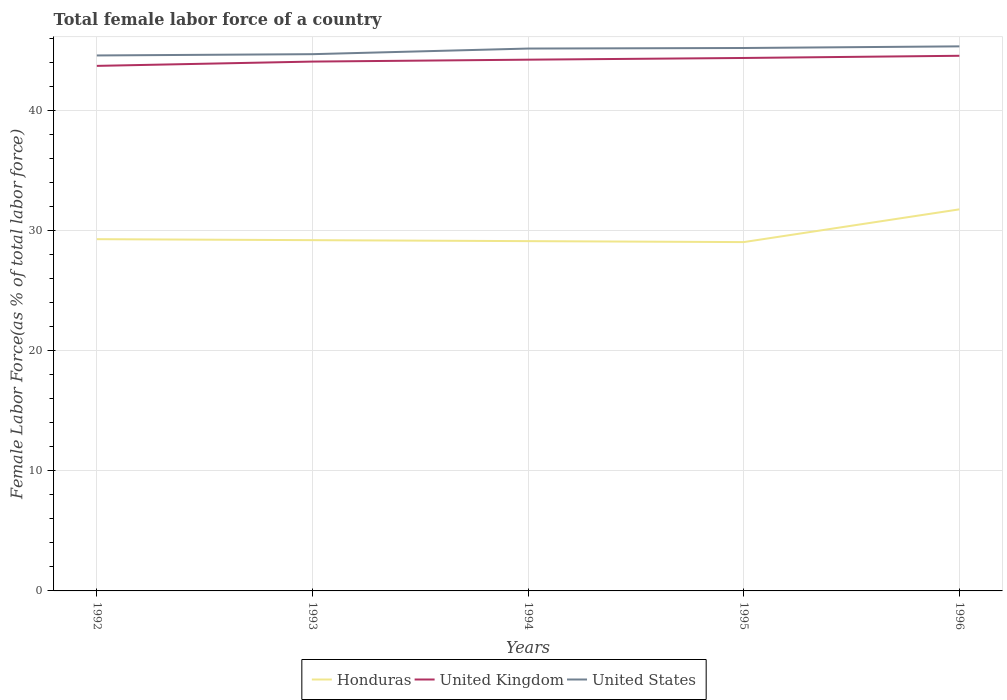Does the line corresponding to United States intersect with the line corresponding to United Kingdom?
Ensure brevity in your answer.  No. Across all years, what is the maximum percentage of female labor force in Honduras?
Provide a succinct answer. 29.04. What is the total percentage of female labor force in United States in the graph?
Your answer should be compact. -0.51. What is the difference between the highest and the second highest percentage of female labor force in United States?
Offer a terse response. 0.76. What is the difference between the highest and the lowest percentage of female labor force in Honduras?
Give a very brief answer. 1. Is the percentage of female labor force in United States strictly greater than the percentage of female labor force in United Kingdom over the years?
Make the answer very short. No. How many years are there in the graph?
Provide a succinct answer. 5. What is the difference between two consecutive major ticks on the Y-axis?
Offer a very short reply. 10. Are the values on the major ticks of Y-axis written in scientific E-notation?
Provide a succinct answer. No. Does the graph contain grids?
Your response must be concise. Yes. Where does the legend appear in the graph?
Offer a very short reply. Bottom center. What is the title of the graph?
Your answer should be very brief. Total female labor force of a country. Does "Burundi" appear as one of the legend labels in the graph?
Ensure brevity in your answer.  No. What is the label or title of the X-axis?
Make the answer very short. Years. What is the label or title of the Y-axis?
Provide a succinct answer. Female Labor Force(as % of total labor force). What is the Female Labor Force(as % of total labor force) in Honduras in 1992?
Your answer should be compact. 29.29. What is the Female Labor Force(as % of total labor force) of United Kingdom in 1992?
Your answer should be very brief. 43.72. What is the Female Labor Force(as % of total labor force) of United States in 1992?
Keep it short and to the point. 44.58. What is the Female Labor Force(as % of total labor force) of Honduras in 1993?
Your response must be concise. 29.2. What is the Female Labor Force(as % of total labor force) in United Kingdom in 1993?
Ensure brevity in your answer.  44.07. What is the Female Labor Force(as % of total labor force) in United States in 1993?
Give a very brief answer. 44.69. What is the Female Labor Force(as % of total labor force) of Honduras in 1994?
Ensure brevity in your answer.  29.12. What is the Female Labor Force(as % of total labor force) in United Kingdom in 1994?
Offer a very short reply. 44.23. What is the Female Labor Force(as % of total labor force) in United States in 1994?
Provide a succinct answer. 45.16. What is the Female Labor Force(as % of total labor force) in Honduras in 1995?
Your answer should be very brief. 29.04. What is the Female Labor Force(as % of total labor force) in United Kingdom in 1995?
Offer a terse response. 44.37. What is the Female Labor Force(as % of total labor force) in United States in 1995?
Give a very brief answer. 45.2. What is the Female Labor Force(as % of total labor force) of Honduras in 1996?
Offer a very short reply. 31.77. What is the Female Labor Force(as % of total labor force) in United Kingdom in 1996?
Keep it short and to the point. 44.56. What is the Female Labor Force(as % of total labor force) in United States in 1996?
Ensure brevity in your answer.  45.34. Across all years, what is the maximum Female Labor Force(as % of total labor force) of Honduras?
Provide a succinct answer. 31.77. Across all years, what is the maximum Female Labor Force(as % of total labor force) in United Kingdom?
Ensure brevity in your answer.  44.56. Across all years, what is the maximum Female Labor Force(as % of total labor force) of United States?
Your response must be concise. 45.34. Across all years, what is the minimum Female Labor Force(as % of total labor force) of Honduras?
Your answer should be very brief. 29.04. Across all years, what is the minimum Female Labor Force(as % of total labor force) in United Kingdom?
Your answer should be very brief. 43.72. Across all years, what is the minimum Female Labor Force(as % of total labor force) of United States?
Make the answer very short. 44.58. What is the total Female Labor Force(as % of total labor force) of Honduras in the graph?
Ensure brevity in your answer.  148.43. What is the total Female Labor Force(as % of total labor force) of United Kingdom in the graph?
Make the answer very short. 220.95. What is the total Female Labor Force(as % of total labor force) of United States in the graph?
Offer a terse response. 224.97. What is the difference between the Female Labor Force(as % of total labor force) in Honduras in 1992 and that in 1993?
Offer a terse response. 0.08. What is the difference between the Female Labor Force(as % of total labor force) of United Kingdom in 1992 and that in 1993?
Provide a short and direct response. -0.36. What is the difference between the Female Labor Force(as % of total labor force) of United States in 1992 and that in 1993?
Provide a short and direct response. -0.11. What is the difference between the Female Labor Force(as % of total labor force) of Honduras in 1992 and that in 1994?
Ensure brevity in your answer.  0.16. What is the difference between the Female Labor Force(as % of total labor force) in United Kingdom in 1992 and that in 1994?
Your answer should be compact. -0.52. What is the difference between the Female Labor Force(as % of total labor force) in United States in 1992 and that in 1994?
Ensure brevity in your answer.  -0.58. What is the difference between the Female Labor Force(as % of total labor force) of Honduras in 1992 and that in 1995?
Provide a succinct answer. 0.24. What is the difference between the Female Labor Force(as % of total labor force) in United Kingdom in 1992 and that in 1995?
Keep it short and to the point. -0.66. What is the difference between the Female Labor Force(as % of total labor force) of United States in 1992 and that in 1995?
Offer a terse response. -0.62. What is the difference between the Female Labor Force(as % of total labor force) of Honduras in 1992 and that in 1996?
Offer a terse response. -2.48. What is the difference between the Female Labor Force(as % of total labor force) in United Kingdom in 1992 and that in 1996?
Offer a terse response. -0.84. What is the difference between the Female Labor Force(as % of total labor force) of United States in 1992 and that in 1996?
Give a very brief answer. -0.76. What is the difference between the Female Labor Force(as % of total labor force) of Honduras in 1993 and that in 1994?
Offer a terse response. 0.08. What is the difference between the Female Labor Force(as % of total labor force) of United Kingdom in 1993 and that in 1994?
Keep it short and to the point. -0.16. What is the difference between the Female Labor Force(as % of total labor force) in United States in 1993 and that in 1994?
Offer a very short reply. -0.47. What is the difference between the Female Labor Force(as % of total labor force) of Honduras in 1993 and that in 1995?
Provide a short and direct response. 0.16. What is the difference between the Female Labor Force(as % of total labor force) of United Kingdom in 1993 and that in 1995?
Offer a terse response. -0.3. What is the difference between the Female Labor Force(as % of total labor force) in United States in 1993 and that in 1995?
Your answer should be very brief. -0.51. What is the difference between the Female Labor Force(as % of total labor force) of Honduras in 1993 and that in 1996?
Your answer should be compact. -2.57. What is the difference between the Female Labor Force(as % of total labor force) in United Kingdom in 1993 and that in 1996?
Offer a terse response. -0.48. What is the difference between the Female Labor Force(as % of total labor force) in United States in 1993 and that in 1996?
Give a very brief answer. -0.65. What is the difference between the Female Labor Force(as % of total labor force) in Honduras in 1994 and that in 1995?
Your answer should be very brief. 0.08. What is the difference between the Female Labor Force(as % of total labor force) in United Kingdom in 1994 and that in 1995?
Offer a very short reply. -0.14. What is the difference between the Female Labor Force(as % of total labor force) in United States in 1994 and that in 1995?
Your answer should be compact. -0.05. What is the difference between the Female Labor Force(as % of total labor force) in Honduras in 1994 and that in 1996?
Keep it short and to the point. -2.65. What is the difference between the Female Labor Force(as % of total labor force) in United Kingdom in 1994 and that in 1996?
Ensure brevity in your answer.  -0.32. What is the difference between the Female Labor Force(as % of total labor force) of United States in 1994 and that in 1996?
Give a very brief answer. -0.18. What is the difference between the Female Labor Force(as % of total labor force) in Honduras in 1995 and that in 1996?
Your response must be concise. -2.73. What is the difference between the Female Labor Force(as % of total labor force) in United Kingdom in 1995 and that in 1996?
Ensure brevity in your answer.  -0.18. What is the difference between the Female Labor Force(as % of total labor force) in United States in 1995 and that in 1996?
Offer a terse response. -0.14. What is the difference between the Female Labor Force(as % of total labor force) in Honduras in 1992 and the Female Labor Force(as % of total labor force) in United Kingdom in 1993?
Give a very brief answer. -14.79. What is the difference between the Female Labor Force(as % of total labor force) of Honduras in 1992 and the Female Labor Force(as % of total labor force) of United States in 1993?
Your answer should be very brief. -15.4. What is the difference between the Female Labor Force(as % of total labor force) of United Kingdom in 1992 and the Female Labor Force(as % of total labor force) of United States in 1993?
Keep it short and to the point. -0.97. What is the difference between the Female Labor Force(as % of total labor force) of Honduras in 1992 and the Female Labor Force(as % of total labor force) of United Kingdom in 1994?
Ensure brevity in your answer.  -14.94. What is the difference between the Female Labor Force(as % of total labor force) in Honduras in 1992 and the Female Labor Force(as % of total labor force) in United States in 1994?
Provide a short and direct response. -15.87. What is the difference between the Female Labor Force(as % of total labor force) of United Kingdom in 1992 and the Female Labor Force(as % of total labor force) of United States in 1994?
Your answer should be very brief. -1.44. What is the difference between the Female Labor Force(as % of total labor force) in Honduras in 1992 and the Female Labor Force(as % of total labor force) in United Kingdom in 1995?
Make the answer very short. -15.09. What is the difference between the Female Labor Force(as % of total labor force) in Honduras in 1992 and the Female Labor Force(as % of total labor force) in United States in 1995?
Offer a terse response. -15.92. What is the difference between the Female Labor Force(as % of total labor force) of United Kingdom in 1992 and the Female Labor Force(as % of total labor force) of United States in 1995?
Your response must be concise. -1.49. What is the difference between the Female Labor Force(as % of total labor force) of Honduras in 1992 and the Female Labor Force(as % of total labor force) of United Kingdom in 1996?
Provide a succinct answer. -15.27. What is the difference between the Female Labor Force(as % of total labor force) in Honduras in 1992 and the Female Labor Force(as % of total labor force) in United States in 1996?
Keep it short and to the point. -16.05. What is the difference between the Female Labor Force(as % of total labor force) in United Kingdom in 1992 and the Female Labor Force(as % of total labor force) in United States in 1996?
Your answer should be very brief. -1.62. What is the difference between the Female Labor Force(as % of total labor force) in Honduras in 1993 and the Female Labor Force(as % of total labor force) in United Kingdom in 1994?
Your answer should be very brief. -15.03. What is the difference between the Female Labor Force(as % of total labor force) of Honduras in 1993 and the Female Labor Force(as % of total labor force) of United States in 1994?
Provide a succinct answer. -15.95. What is the difference between the Female Labor Force(as % of total labor force) in United Kingdom in 1993 and the Female Labor Force(as % of total labor force) in United States in 1994?
Your response must be concise. -1.08. What is the difference between the Female Labor Force(as % of total labor force) of Honduras in 1993 and the Female Labor Force(as % of total labor force) of United Kingdom in 1995?
Your answer should be compact. -15.17. What is the difference between the Female Labor Force(as % of total labor force) in Honduras in 1993 and the Female Labor Force(as % of total labor force) in United States in 1995?
Your answer should be compact. -16. What is the difference between the Female Labor Force(as % of total labor force) of United Kingdom in 1993 and the Female Labor Force(as % of total labor force) of United States in 1995?
Provide a succinct answer. -1.13. What is the difference between the Female Labor Force(as % of total labor force) in Honduras in 1993 and the Female Labor Force(as % of total labor force) in United Kingdom in 1996?
Make the answer very short. -15.35. What is the difference between the Female Labor Force(as % of total labor force) of Honduras in 1993 and the Female Labor Force(as % of total labor force) of United States in 1996?
Provide a short and direct response. -16.14. What is the difference between the Female Labor Force(as % of total labor force) of United Kingdom in 1993 and the Female Labor Force(as % of total labor force) of United States in 1996?
Your response must be concise. -1.27. What is the difference between the Female Labor Force(as % of total labor force) in Honduras in 1994 and the Female Labor Force(as % of total labor force) in United Kingdom in 1995?
Give a very brief answer. -15.25. What is the difference between the Female Labor Force(as % of total labor force) of Honduras in 1994 and the Female Labor Force(as % of total labor force) of United States in 1995?
Your response must be concise. -16.08. What is the difference between the Female Labor Force(as % of total labor force) in United Kingdom in 1994 and the Female Labor Force(as % of total labor force) in United States in 1995?
Your response must be concise. -0.97. What is the difference between the Female Labor Force(as % of total labor force) of Honduras in 1994 and the Female Labor Force(as % of total labor force) of United Kingdom in 1996?
Give a very brief answer. -15.43. What is the difference between the Female Labor Force(as % of total labor force) of Honduras in 1994 and the Female Labor Force(as % of total labor force) of United States in 1996?
Your answer should be compact. -16.22. What is the difference between the Female Labor Force(as % of total labor force) of United Kingdom in 1994 and the Female Labor Force(as % of total labor force) of United States in 1996?
Make the answer very short. -1.11. What is the difference between the Female Labor Force(as % of total labor force) of Honduras in 1995 and the Female Labor Force(as % of total labor force) of United Kingdom in 1996?
Provide a short and direct response. -15.51. What is the difference between the Female Labor Force(as % of total labor force) in Honduras in 1995 and the Female Labor Force(as % of total labor force) in United States in 1996?
Keep it short and to the point. -16.3. What is the difference between the Female Labor Force(as % of total labor force) of United Kingdom in 1995 and the Female Labor Force(as % of total labor force) of United States in 1996?
Offer a very short reply. -0.97. What is the average Female Labor Force(as % of total labor force) of Honduras per year?
Your response must be concise. 29.69. What is the average Female Labor Force(as % of total labor force) of United Kingdom per year?
Offer a very short reply. 44.19. What is the average Female Labor Force(as % of total labor force) of United States per year?
Ensure brevity in your answer.  44.99. In the year 1992, what is the difference between the Female Labor Force(as % of total labor force) of Honduras and Female Labor Force(as % of total labor force) of United Kingdom?
Offer a terse response. -14.43. In the year 1992, what is the difference between the Female Labor Force(as % of total labor force) in Honduras and Female Labor Force(as % of total labor force) in United States?
Provide a succinct answer. -15.3. In the year 1992, what is the difference between the Female Labor Force(as % of total labor force) in United Kingdom and Female Labor Force(as % of total labor force) in United States?
Ensure brevity in your answer.  -0.87. In the year 1993, what is the difference between the Female Labor Force(as % of total labor force) of Honduras and Female Labor Force(as % of total labor force) of United Kingdom?
Ensure brevity in your answer.  -14.87. In the year 1993, what is the difference between the Female Labor Force(as % of total labor force) of Honduras and Female Labor Force(as % of total labor force) of United States?
Offer a terse response. -15.49. In the year 1993, what is the difference between the Female Labor Force(as % of total labor force) in United Kingdom and Female Labor Force(as % of total labor force) in United States?
Offer a very short reply. -0.62. In the year 1994, what is the difference between the Female Labor Force(as % of total labor force) of Honduras and Female Labor Force(as % of total labor force) of United Kingdom?
Offer a very short reply. -15.11. In the year 1994, what is the difference between the Female Labor Force(as % of total labor force) in Honduras and Female Labor Force(as % of total labor force) in United States?
Keep it short and to the point. -16.03. In the year 1994, what is the difference between the Female Labor Force(as % of total labor force) in United Kingdom and Female Labor Force(as % of total labor force) in United States?
Make the answer very short. -0.93. In the year 1995, what is the difference between the Female Labor Force(as % of total labor force) of Honduras and Female Labor Force(as % of total labor force) of United Kingdom?
Your answer should be compact. -15.33. In the year 1995, what is the difference between the Female Labor Force(as % of total labor force) in Honduras and Female Labor Force(as % of total labor force) in United States?
Offer a terse response. -16.16. In the year 1995, what is the difference between the Female Labor Force(as % of total labor force) of United Kingdom and Female Labor Force(as % of total labor force) of United States?
Offer a terse response. -0.83. In the year 1996, what is the difference between the Female Labor Force(as % of total labor force) in Honduras and Female Labor Force(as % of total labor force) in United Kingdom?
Make the answer very short. -12.79. In the year 1996, what is the difference between the Female Labor Force(as % of total labor force) in Honduras and Female Labor Force(as % of total labor force) in United States?
Ensure brevity in your answer.  -13.57. In the year 1996, what is the difference between the Female Labor Force(as % of total labor force) of United Kingdom and Female Labor Force(as % of total labor force) of United States?
Offer a very short reply. -0.78. What is the ratio of the Female Labor Force(as % of total labor force) of United Kingdom in 1992 to that in 1993?
Your answer should be compact. 0.99. What is the ratio of the Female Labor Force(as % of total labor force) of Honduras in 1992 to that in 1994?
Offer a very short reply. 1.01. What is the ratio of the Female Labor Force(as % of total labor force) in United Kingdom in 1992 to that in 1994?
Give a very brief answer. 0.99. What is the ratio of the Female Labor Force(as % of total labor force) in United States in 1992 to that in 1994?
Provide a succinct answer. 0.99. What is the ratio of the Female Labor Force(as % of total labor force) in Honduras in 1992 to that in 1995?
Ensure brevity in your answer.  1.01. What is the ratio of the Female Labor Force(as % of total labor force) in United Kingdom in 1992 to that in 1995?
Keep it short and to the point. 0.99. What is the ratio of the Female Labor Force(as % of total labor force) in United States in 1992 to that in 1995?
Keep it short and to the point. 0.99. What is the ratio of the Female Labor Force(as % of total labor force) of Honduras in 1992 to that in 1996?
Keep it short and to the point. 0.92. What is the ratio of the Female Labor Force(as % of total labor force) in United Kingdom in 1992 to that in 1996?
Ensure brevity in your answer.  0.98. What is the ratio of the Female Labor Force(as % of total labor force) in United States in 1992 to that in 1996?
Your response must be concise. 0.98. What is the ratio of the Female Labor Force(as % of total labor force) of United Kingdom in 1993 to that in 1994?
Offer a terse response. 1. What is the ratio of the Female Labor Force(as % of total labor force) of United States in 1993 to that in 1994?
Ensure brevity in your answer.  0.99. What is the ratio of the Female Labor Force(as % of total labor force) in Honduras in 1993 to that in 1995?
Give a very brief answer. 1.01. What is the ratio of the Female Labor Force(as % of total labor force) in United Kingdom in 1993 to that in 1995?
Offer a terse response. 0.99. What is the ratio of the Female Labor Force(as % of total labor force) in Honduras in 1993 to that in 1996?
Ensure brevity in your answer.  0.92. What is the ratio of the Female Labor Force(as % of total labor force) of United States in 1993 to that in 1996?
Make the answer very short. 0.99. What is the ratio of the Female Labor Force(as % of total labor force) in Honduras in 1994 to that in 1995?
Provide a short and direct response. 1. What is the ratio of the Female Labor Force(as % of total labor force) in United Kingdom in 1994 to that in 1995?
Offer a terse response. 1. What is the ratio of the Female Labor Force(as % of total labor force) in United States in 1994 to that in 1996?
Keep it short and to the point. 1. What is the ratio of the Female Labor Force(as % of total labor force) of Honduras in 1995 to that in 1996?
Ensure brevity in your answer.  0.91. What is the ratio of the Female Labor Force(as % of total labor force) of United States in 1995 to that in 1996?
Ensure brevity in your answer.  1. What is the difference between the highest and the second highest Female Labor Force(as % of total labor force) of Honduras?
Give a very brief answer. 2.48. What is the difference between the highest and the second highest Female Labor Force(as % of total labor force) in United Kingdom?
Your response must be concise. 0.18. What is the difference between the highest and the second highest Female Labor Force(as % of total labor force) in United States?
Provide a short and direct response. 0.14. What is the difference between the highest and the lowest Female Labor Force(as % of total labor force) of Honduras?
Provide a succinct answer. 2.73. What is the difference between the highest and the lowest Female Labor Force(as % of total labor force) in United Kingdom?
Your answer should be compact. 0.84. What is the difference between the highest and the lowest Female Labor Force(as % of total labor force) in United States?
Your response must be concise. 0.76. 